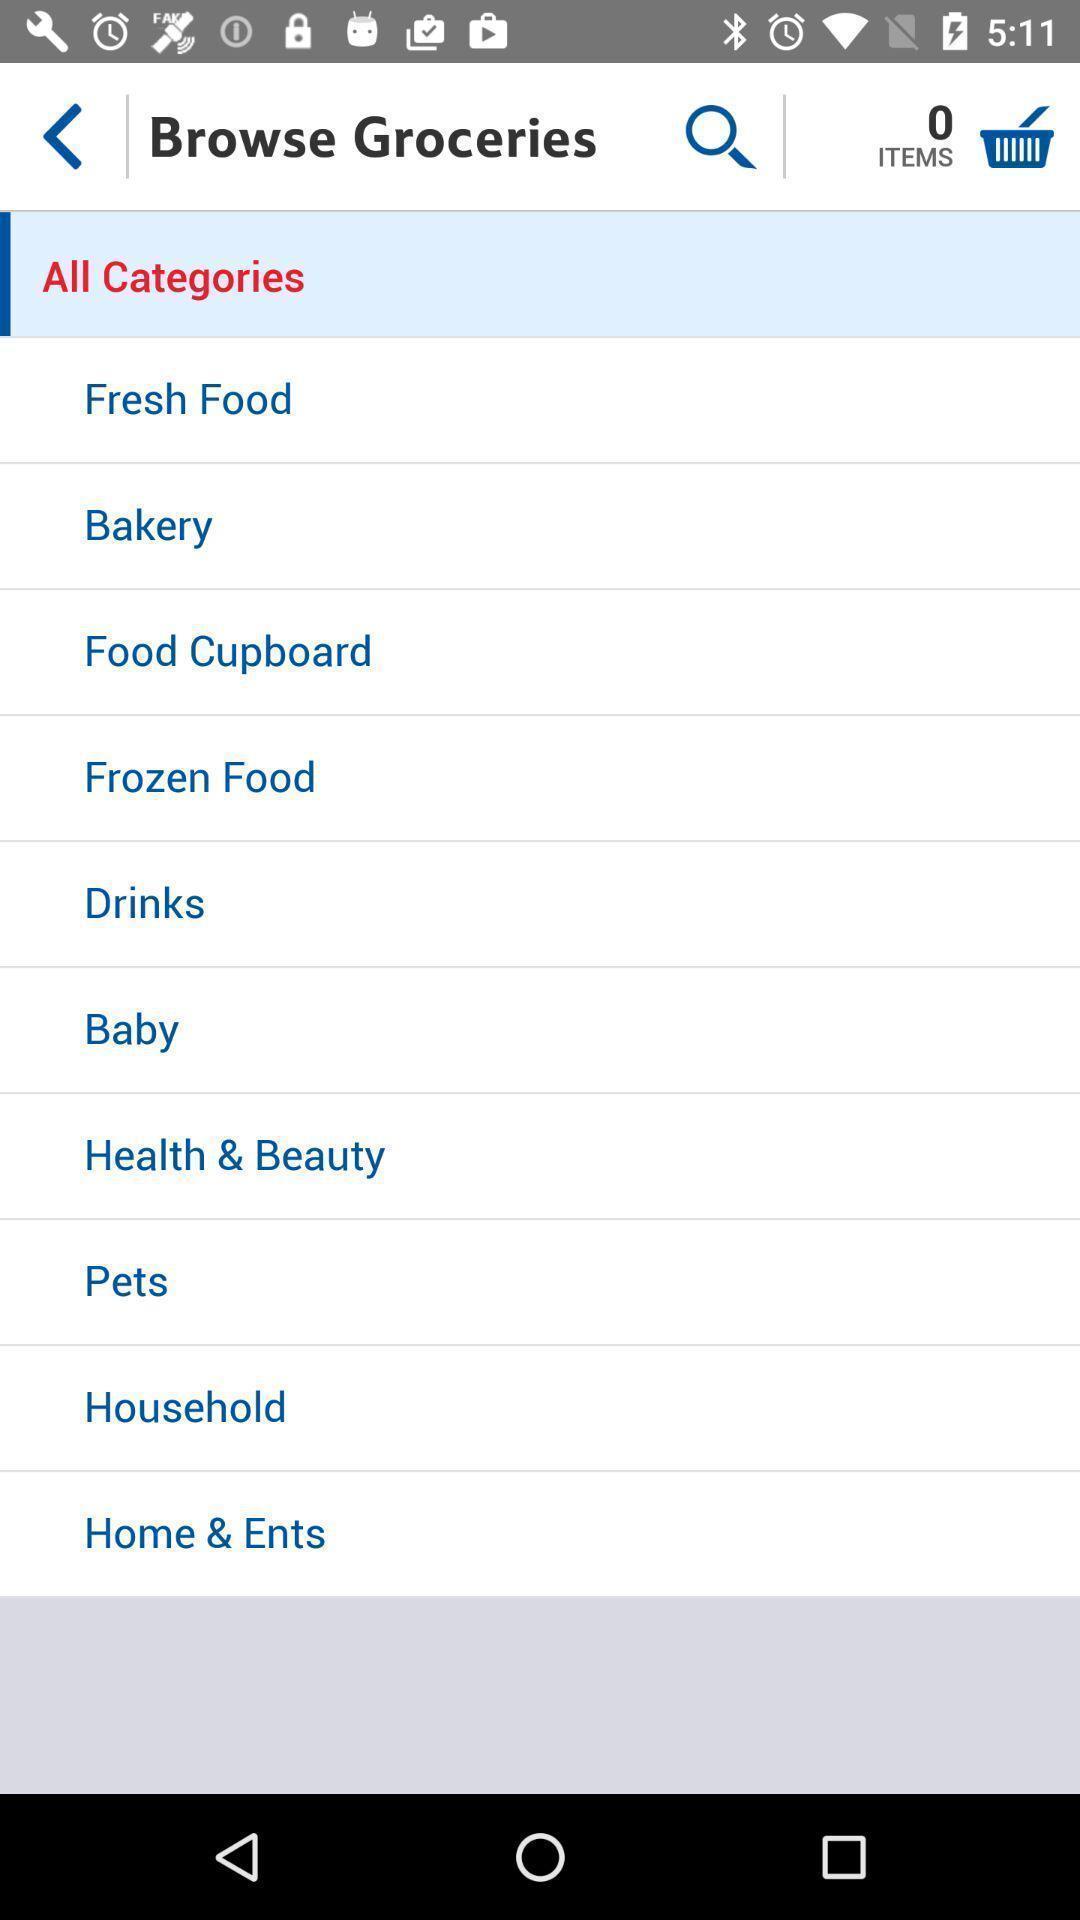Please provide a description for this image. Screen displaying of food applications. 